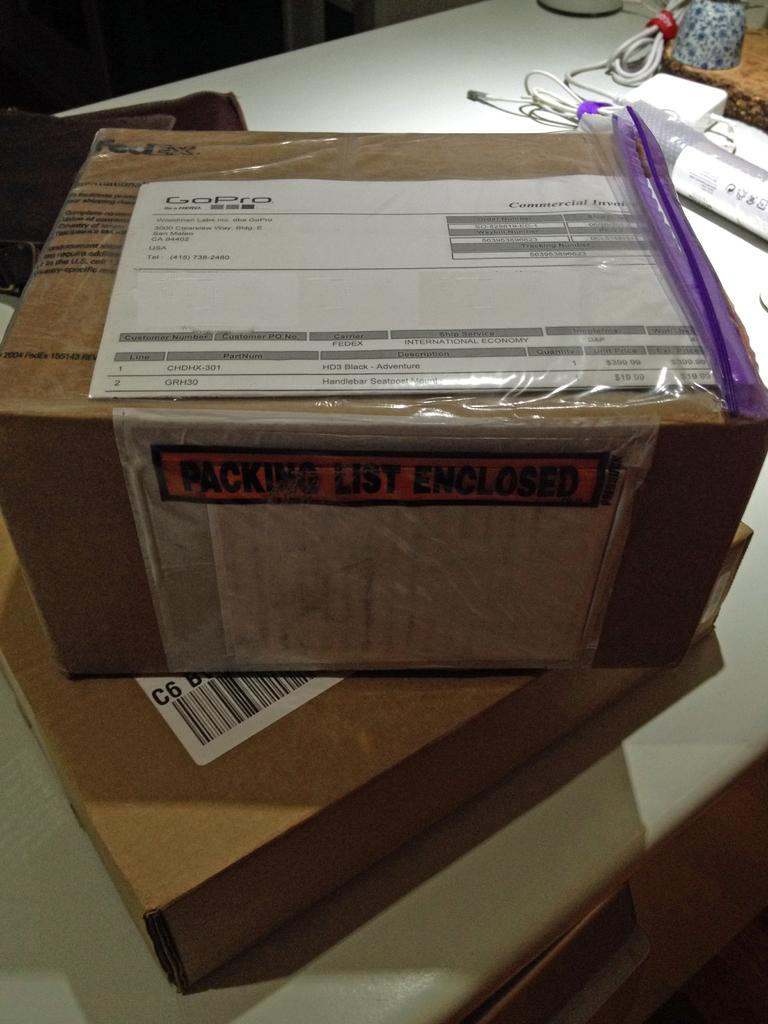Provide a one-sentence caption for the provided image. The box appears to be from GoPro company. 